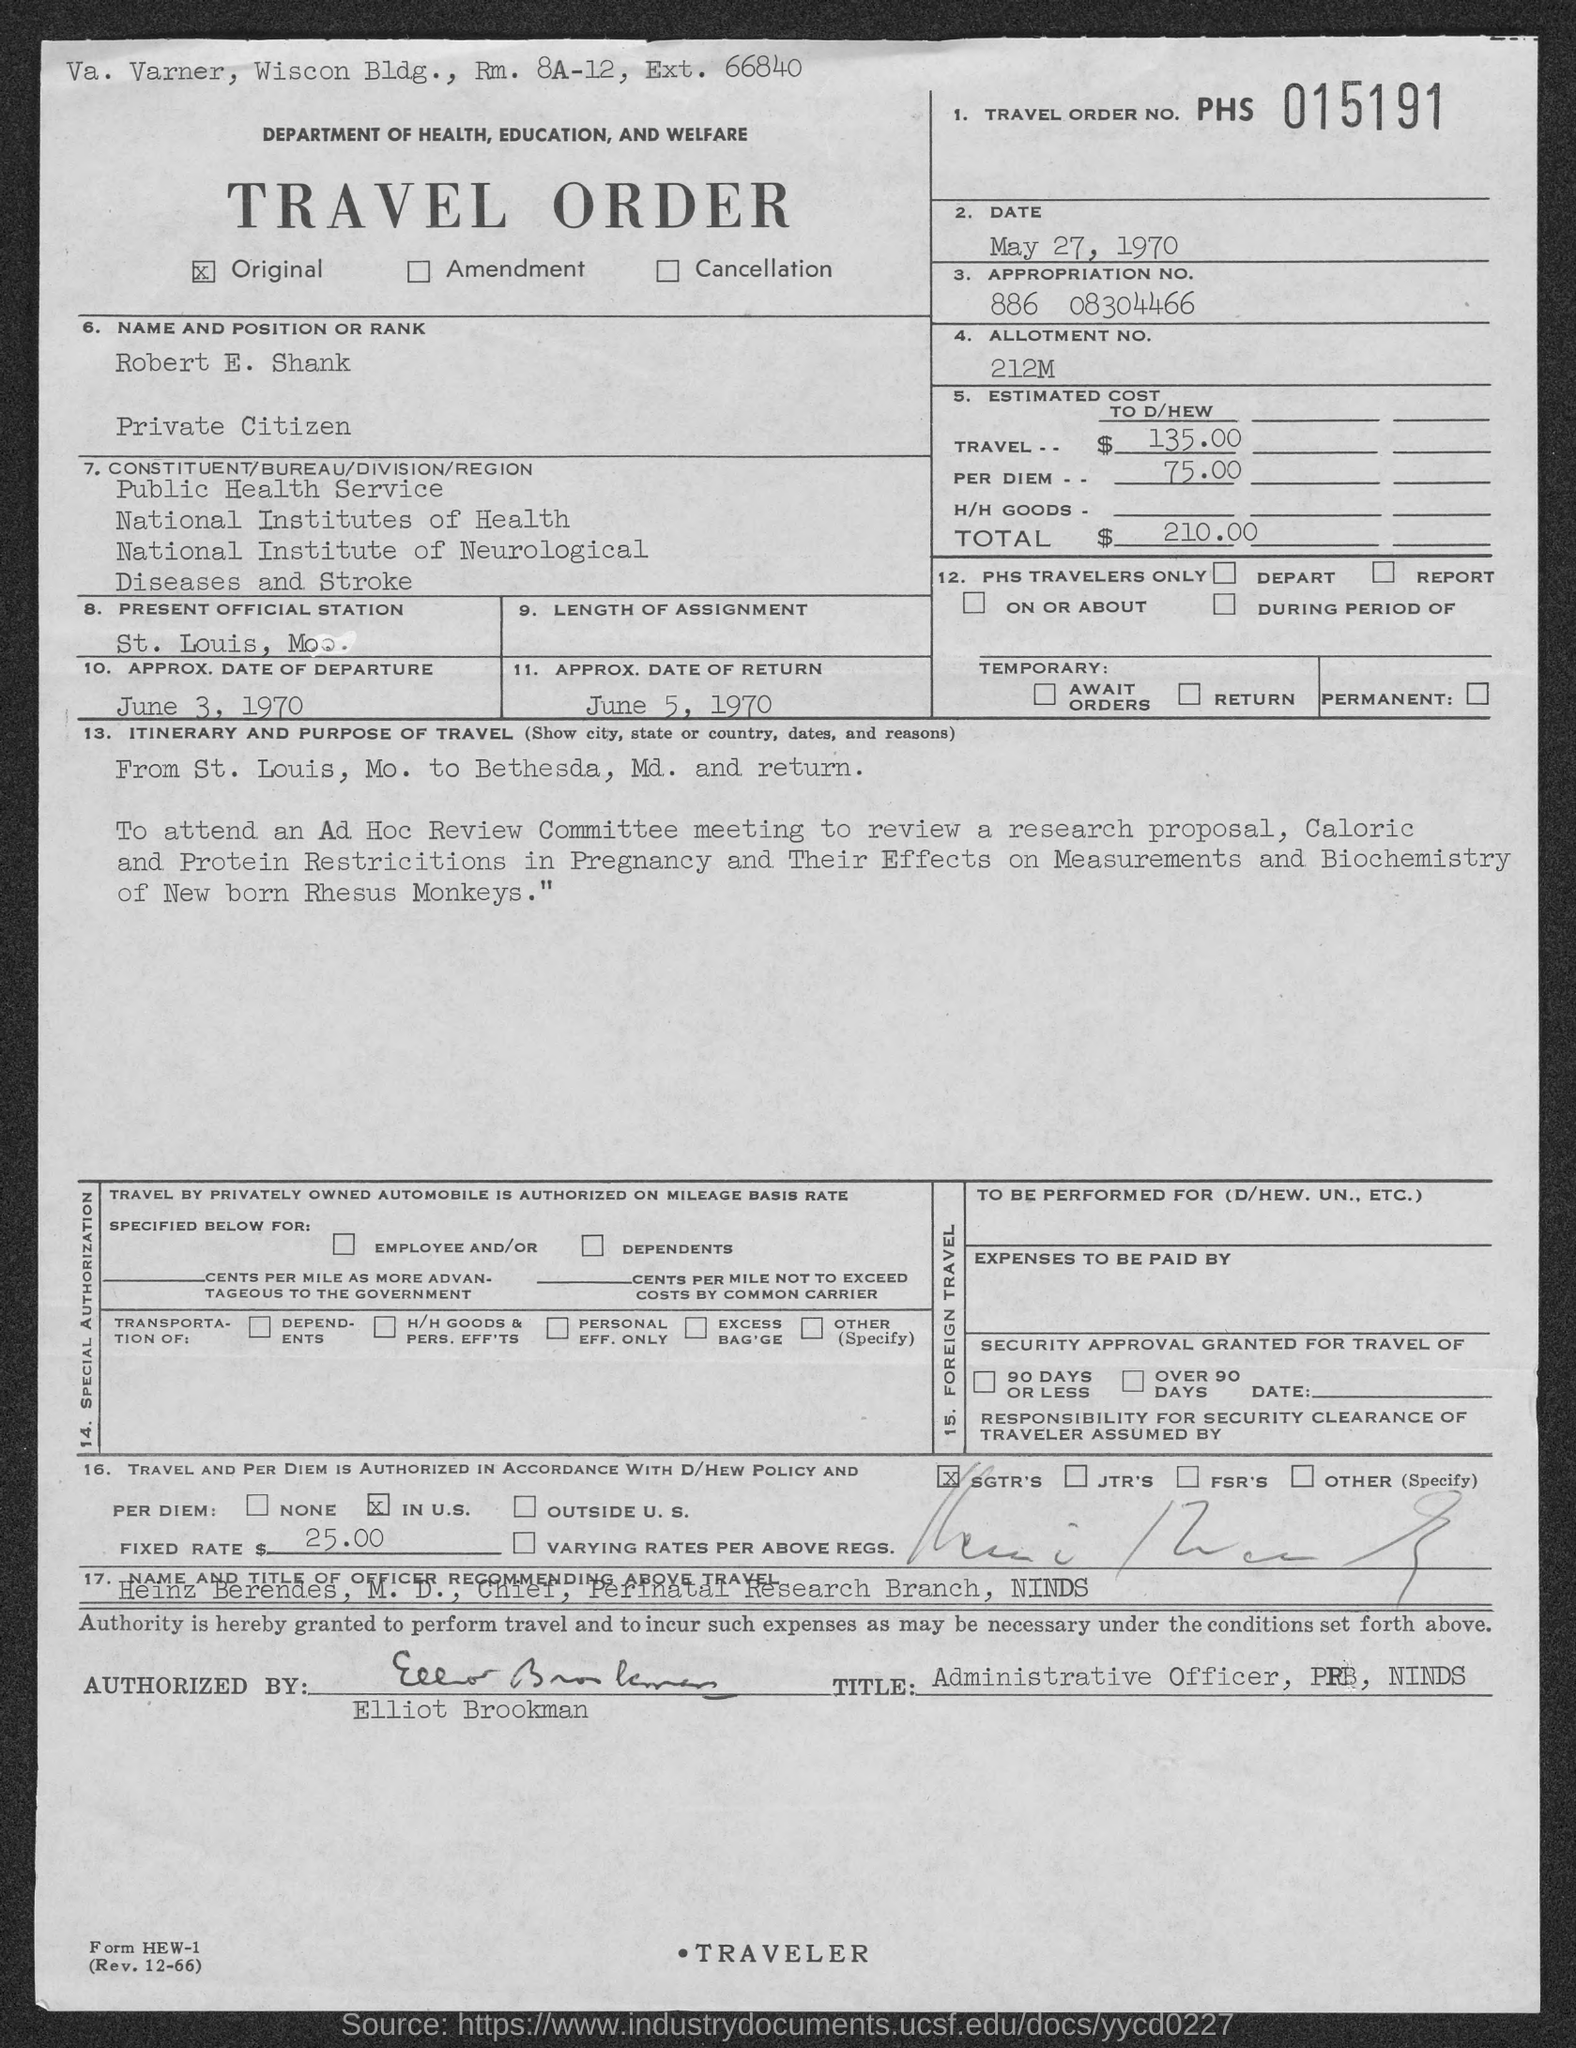Specify some key components in this picture. The date in travel order is May 27, 1970. The approximate date of return is June 5, 1970. The travel order is original. The approximate date of departure is June 3, 1970. The estimated total costs are 210. 